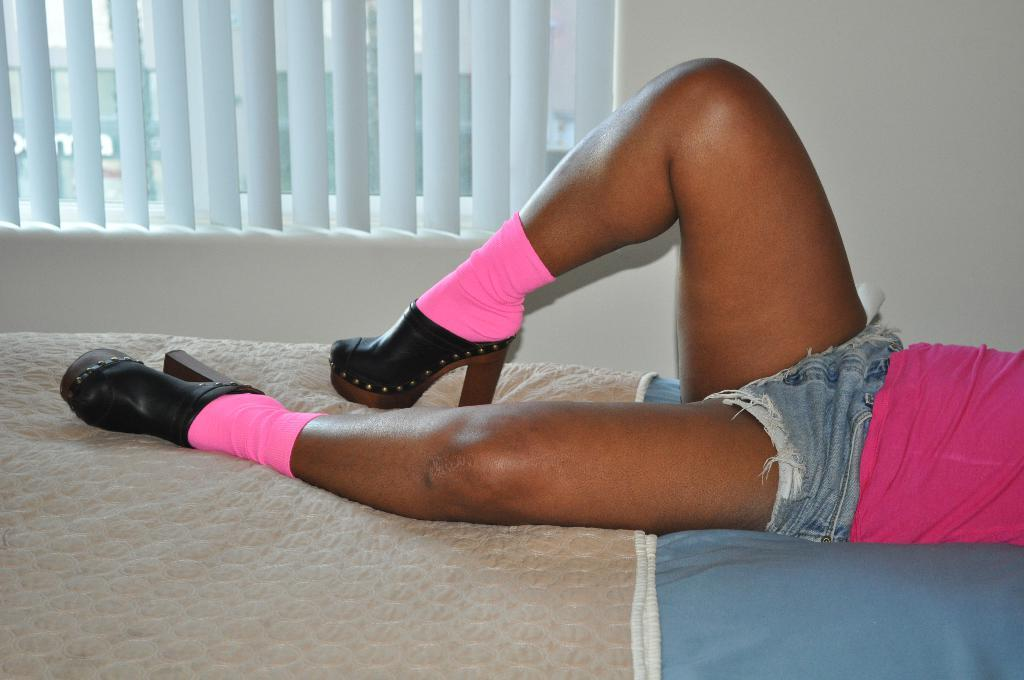Who is the main subject in the image? There is a woman in the center of the image. What is the woman doing in the image? The woman is lying on a bed. What color socks is the woman wearing? The woman is wearing pink color socks. What type of footwear is the woman wearing? The woman is wearing black color shoes. What can be seen in the background of the image? There is a window blind in the background area. What type of crate is visible in the image? There is no crate present in the image. What kind of plant can be seen growing near the woman in the image? There is no plant visible in the image. 